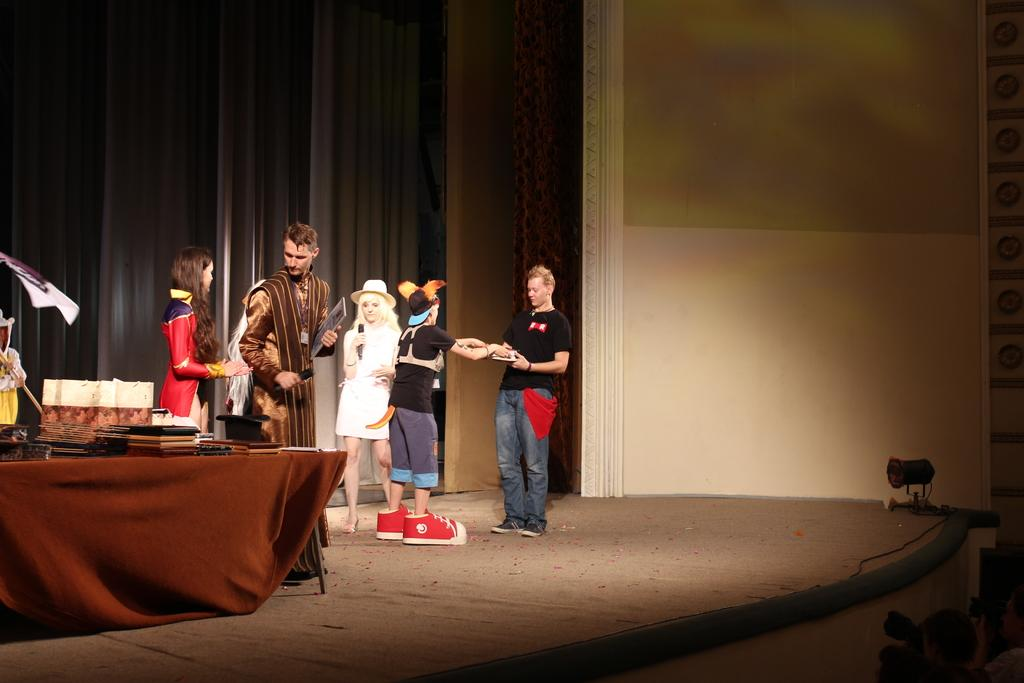What is happening on the stage in the image? There is a group of people standing on the stage. What can be seen on the table in the image? There are items on a table. What is the person holding in the image? A person is holding an item. What type of backdrop is present in the image? There are curtains in the image. What is the purpose of the light in the image? There is a focus light in the image, which is likely used to highlight specific areas or subjects. How many letters are on the bed in the image? There is no bed present in the image, and therefore no letters can be found on it. What type of giants are visible in the image? There are no giants present in the image. 